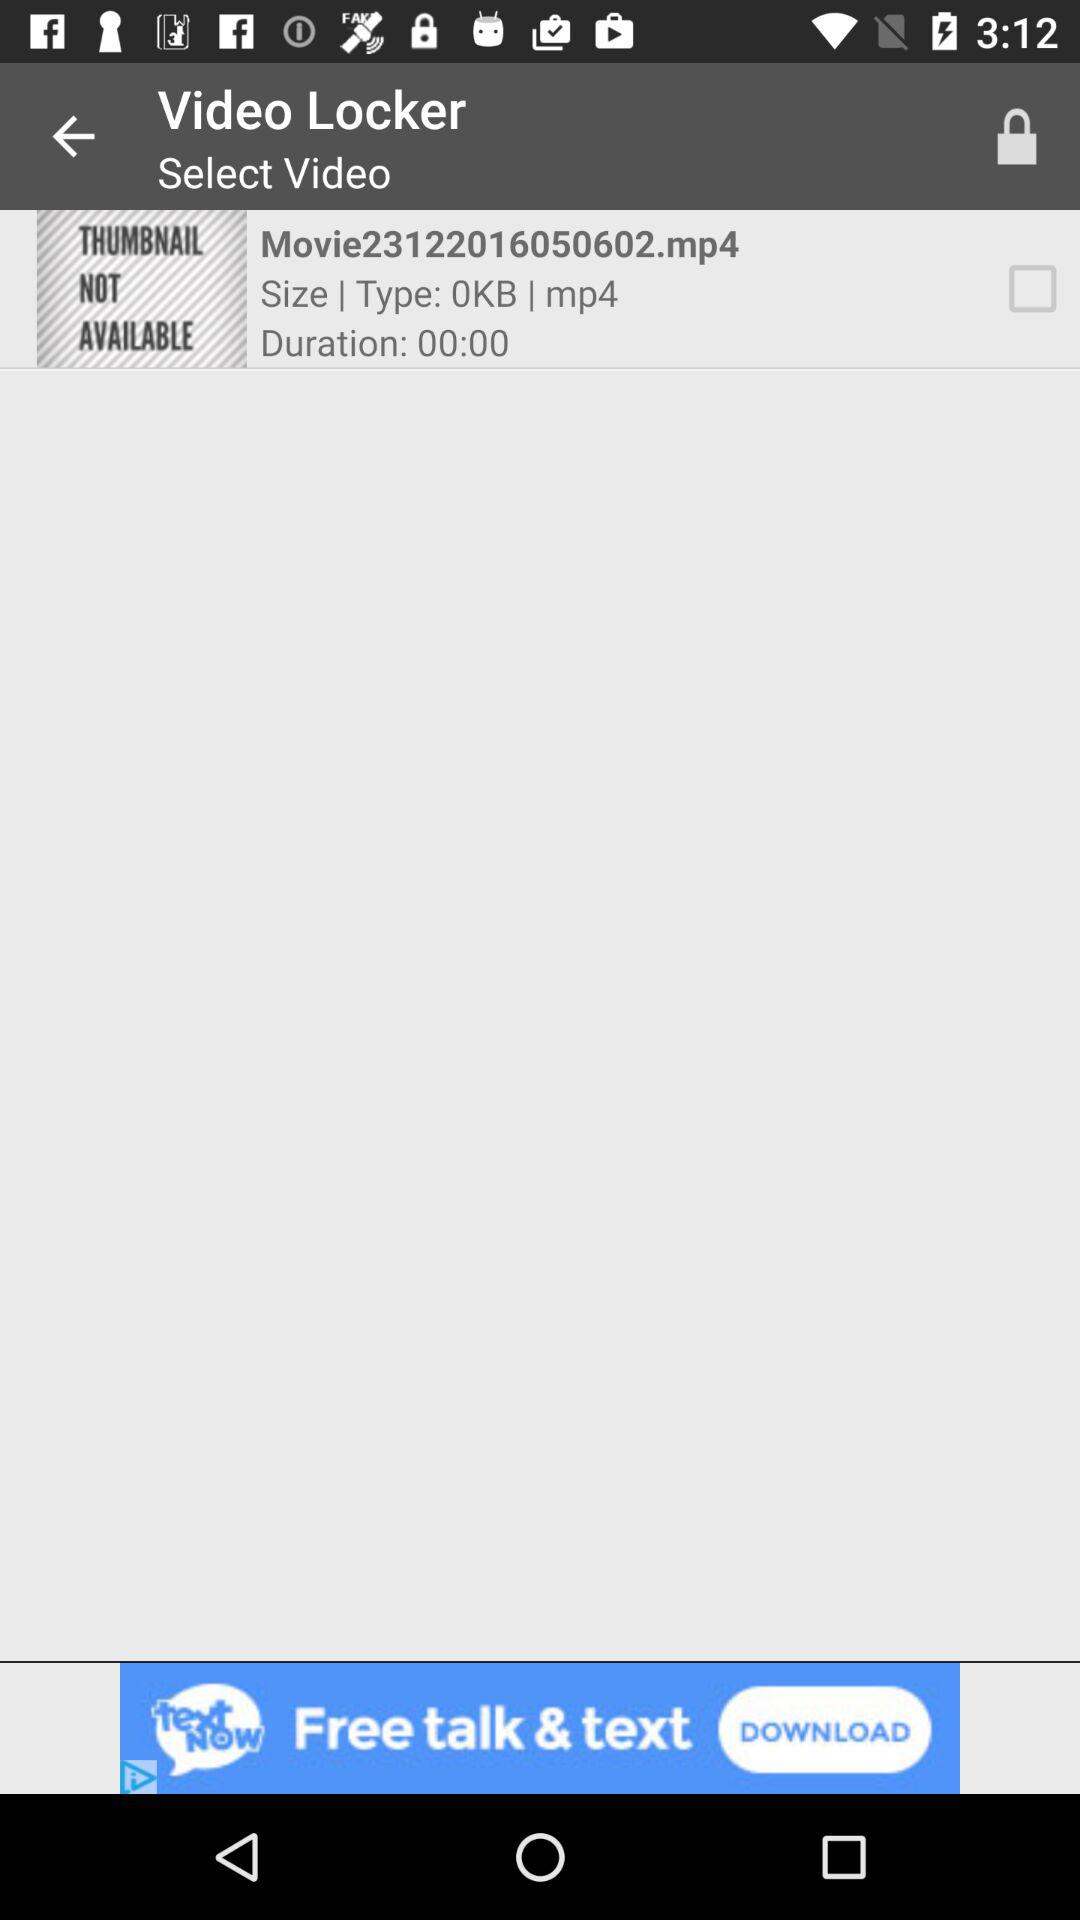What is the size of the video locker? The size of the video locker is 0KB. 